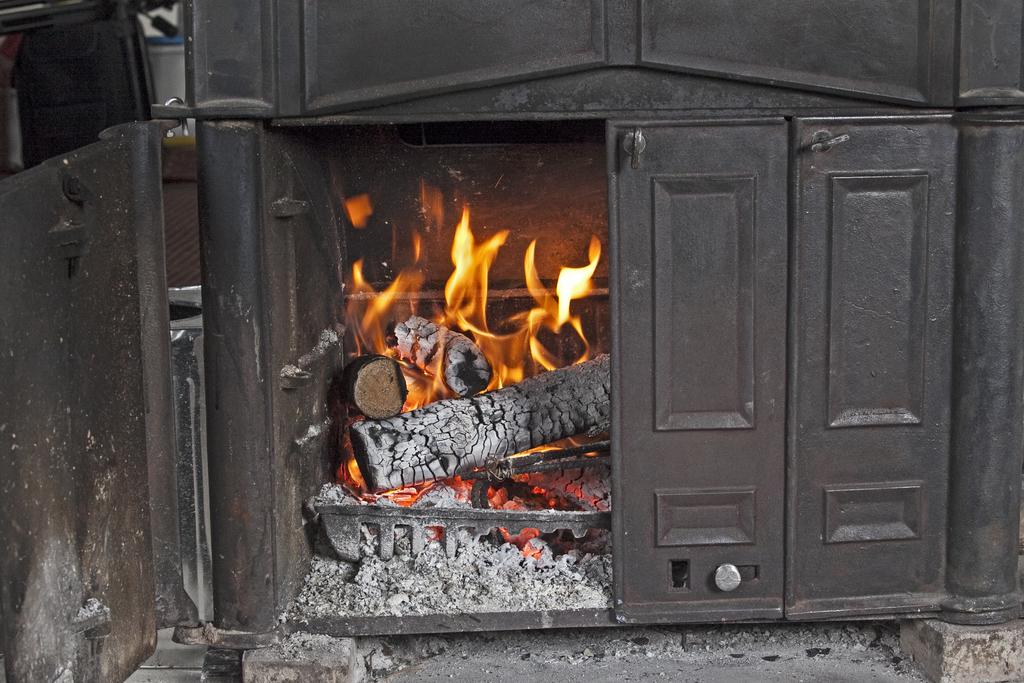What type of structure is present in the image? There is a fireplace in the image. What can be seen inside the fireplace? Ash is visible in the image. What is the color of the object on top of the image? There is a black color thing on top of the image. How does the fireplace celebrate the birthday in the image? The fireplace does not celebrate a birthday in the image, as there is no mention of a birthday or any related elements. 